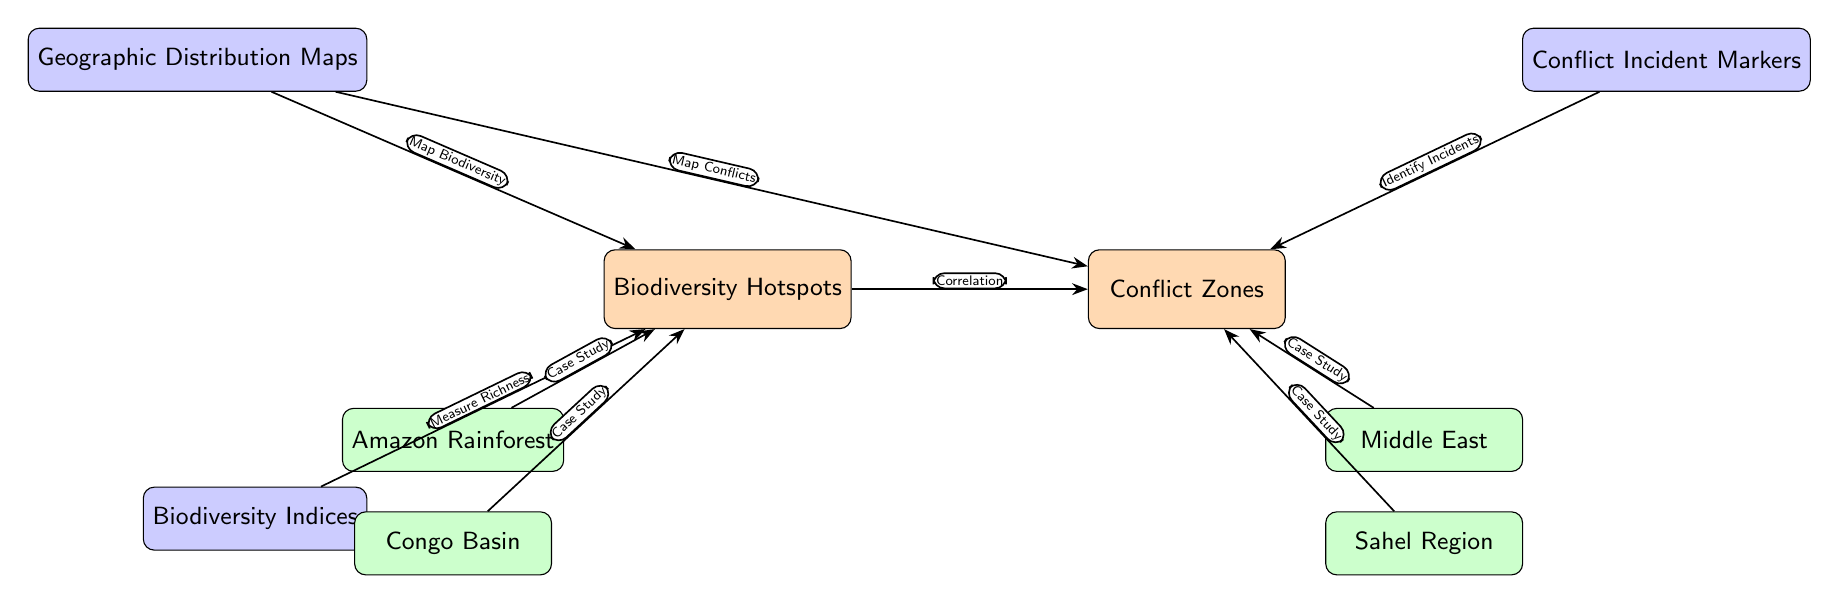What are the two main nodes represented in the diagram? The diagram has two main nodes identified clearly at the top positions: "Biodiversity Hotspots" and "Conflict Zones."
Answer: Biodiversity Hotspots, Conflict Zones How many case study examples are listed under biodiversity hotspots? There are two case study examples shown beneath the "Biodiversity Hotspots" node: "Amazon Rainforest" and "Congo Basin."
Answer: 2 What connects the "Geographic Distribution Maps" node to the "Biodiversity Hotspots"? There is a directed edge labeled "Map Biodiversity" that links the "Geographic Distribution Maps" node to the "Biodiversity Hotspots" node.
Answer: Map Biodiversity Which conflict zone is located below the "Conflict Incident Markers" node? The diagram lists "Middle East" and "Sahel Region" as conflict zones under the "Conflict Incident Markers" node, with "Sahel Region" located directly below "Middle East."
Answer: Sahel Region What type of relationship is indicated between biodiversity hotspots and conflict zones? The diagram indicates a "Correlation" relationship connecting the main nodes of "Biodiversity Hotspots" and "Conflict Zones."
Answer: Correlation How many edges lead out from the "Conflict Zones" node? There are two edges emanating from the "Conflict Zones" node clearly linking to inputs such as "Identify Incidents" from "Conflict Incident Markers" and "Case Study" examples.
Answer: 2 What is measured by the "Biodiversity Indices" node in relation to biodiversity hotspots? The edge from the "Biodiversity Indices" node shows it is used to "Measure Richness" in reference to biodiversity hotspots.
Answer: Measure Richness Which nodes are represented as examples under the biodiversity hotspots category? The examples under the biodiversity hotspots category are "Amazon Rainforest" and "Congo Basin," clearly indicated in the diagram as case studies.
Answer: Amazon Rainforest, Congo Basin What specific edge label connects "Geographic Distribution Maps" to "Conflict Zones"? The label "Map Conflicts" clearly connects the "Geographic Distribution Maps" node to the "Conflict Zones" node, indicating its role in mapping out the conflicts.
Answer: Map Conflicts 